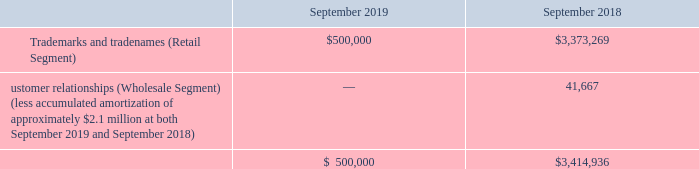Other intangible assets at fiscal year ends 2019 and 2018 consisted of the following:
Goodwill, trademarks and tradenames are considered to have indefinite useful lives and therefore no amortization has been taken on these assets. The Company’s retail reporting unit recorded intangible asset (trademarks and tradenames) impairment charges of approximately $2.9 million during fiscal 2019 and goodwill impairment charges of approximately $1.9 million during fiscal 2018 when it was determined that the carrying values of these assets exceeded their fair values. These impairment charges arose from a range of considerations including, but not limited to, heightened competition in the industry, retail sector market conditions, and earning shortfalls which impacted the Company’s projections of future cash flows to be generated. These impairment charges were recorded in the Company’s consolidated statement of operations as a component of operating income.
Goodwill recorded on the Company’s consolidated balance sheet represents amounts allocated to its wholesale reporting unit which totaled $4.4 million at both September 2019 and September 2018. The Company determined that the estimated fair value of its wholesale reporting unit exceeded its carrying value at both September 2019 and September 2018.
What does goodwill recorded on the Company’s consolidated balance sheet represent? Represents amounts allocated to its wholesale reporting unit. What are the respective intangible asset impairment charges during fiscal 2018 and 2019? $1.9 million, $2.9 million. What are the respective trademarks and tradenames at the end of fiscal year 2018 and 2019? $3,373,269, $500,000. What is the percentage change in the value of the company's trademarks and tradenames between 2018 and 2019?
Answer scale should be: percent. (500,000 - 3,373,269)/3,373,269 
Answer: -85.18. What is the percentage change in the value of company's customer relationships between 2018 and 2019?
Answer scale should be: percent. (0 - 41,667)/41,667 
Answer: -100. What is the value of the company's trademarks and tradenames as a percentage of its total intangible assets in 2018?
Answer scale should be: percent. 3,373,269/3,414,936 
Answer: 98.78. 